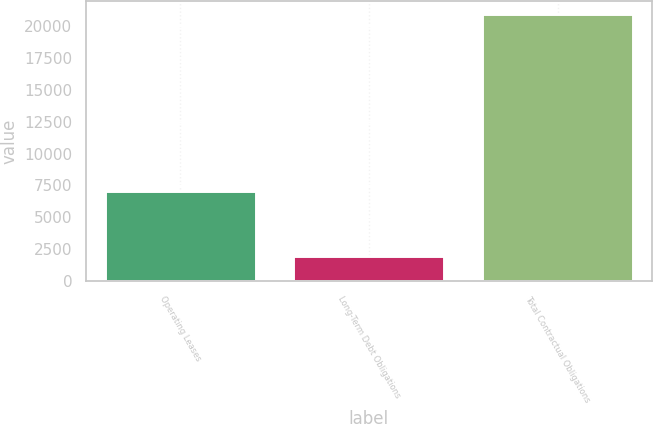Convert chart. <chart><loc_0><loc_0><loc_500><loc_500><bar_chart><fcel>Operating Leases<fcel>Long-Term Debt Obligations<fcel>Total Contractual Obligations<nl><fcel>7071<fcel>1977<fcel>20910<nl></chart> 